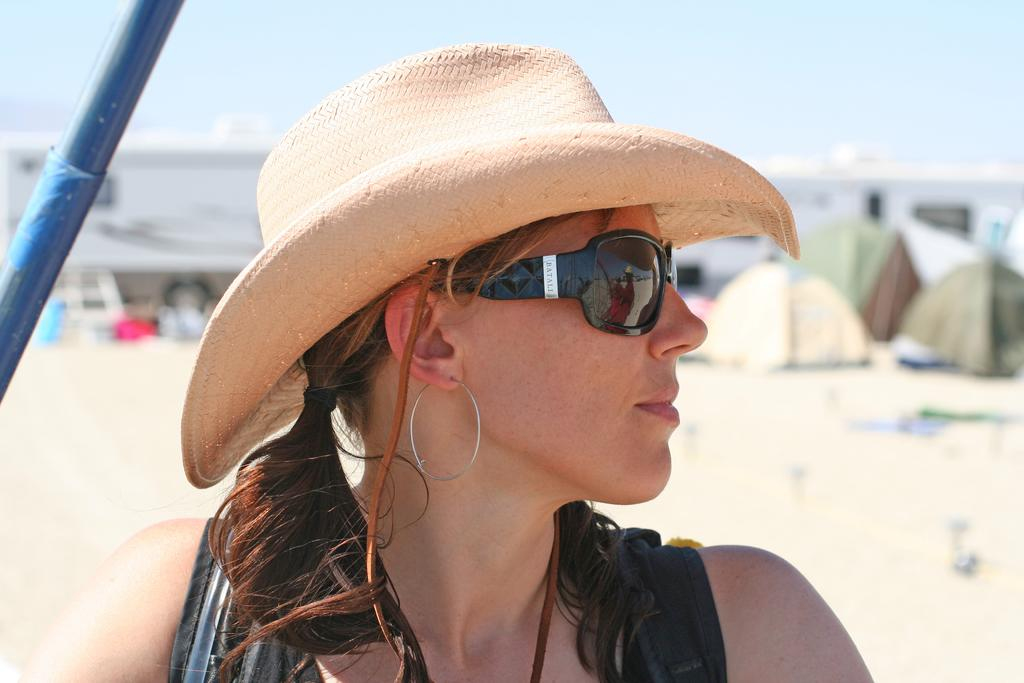Who is the main subject in the foreground of the image? There is a woman in the foreground of the image. What protective gear is the woman wearing? The woman is wearing goggles. What type of headwear is the woman wearing? The woman is wearing a hat. What error message is displayed on the woman's hat in the image? There is no error message displayed on the woman's hat in the image. 